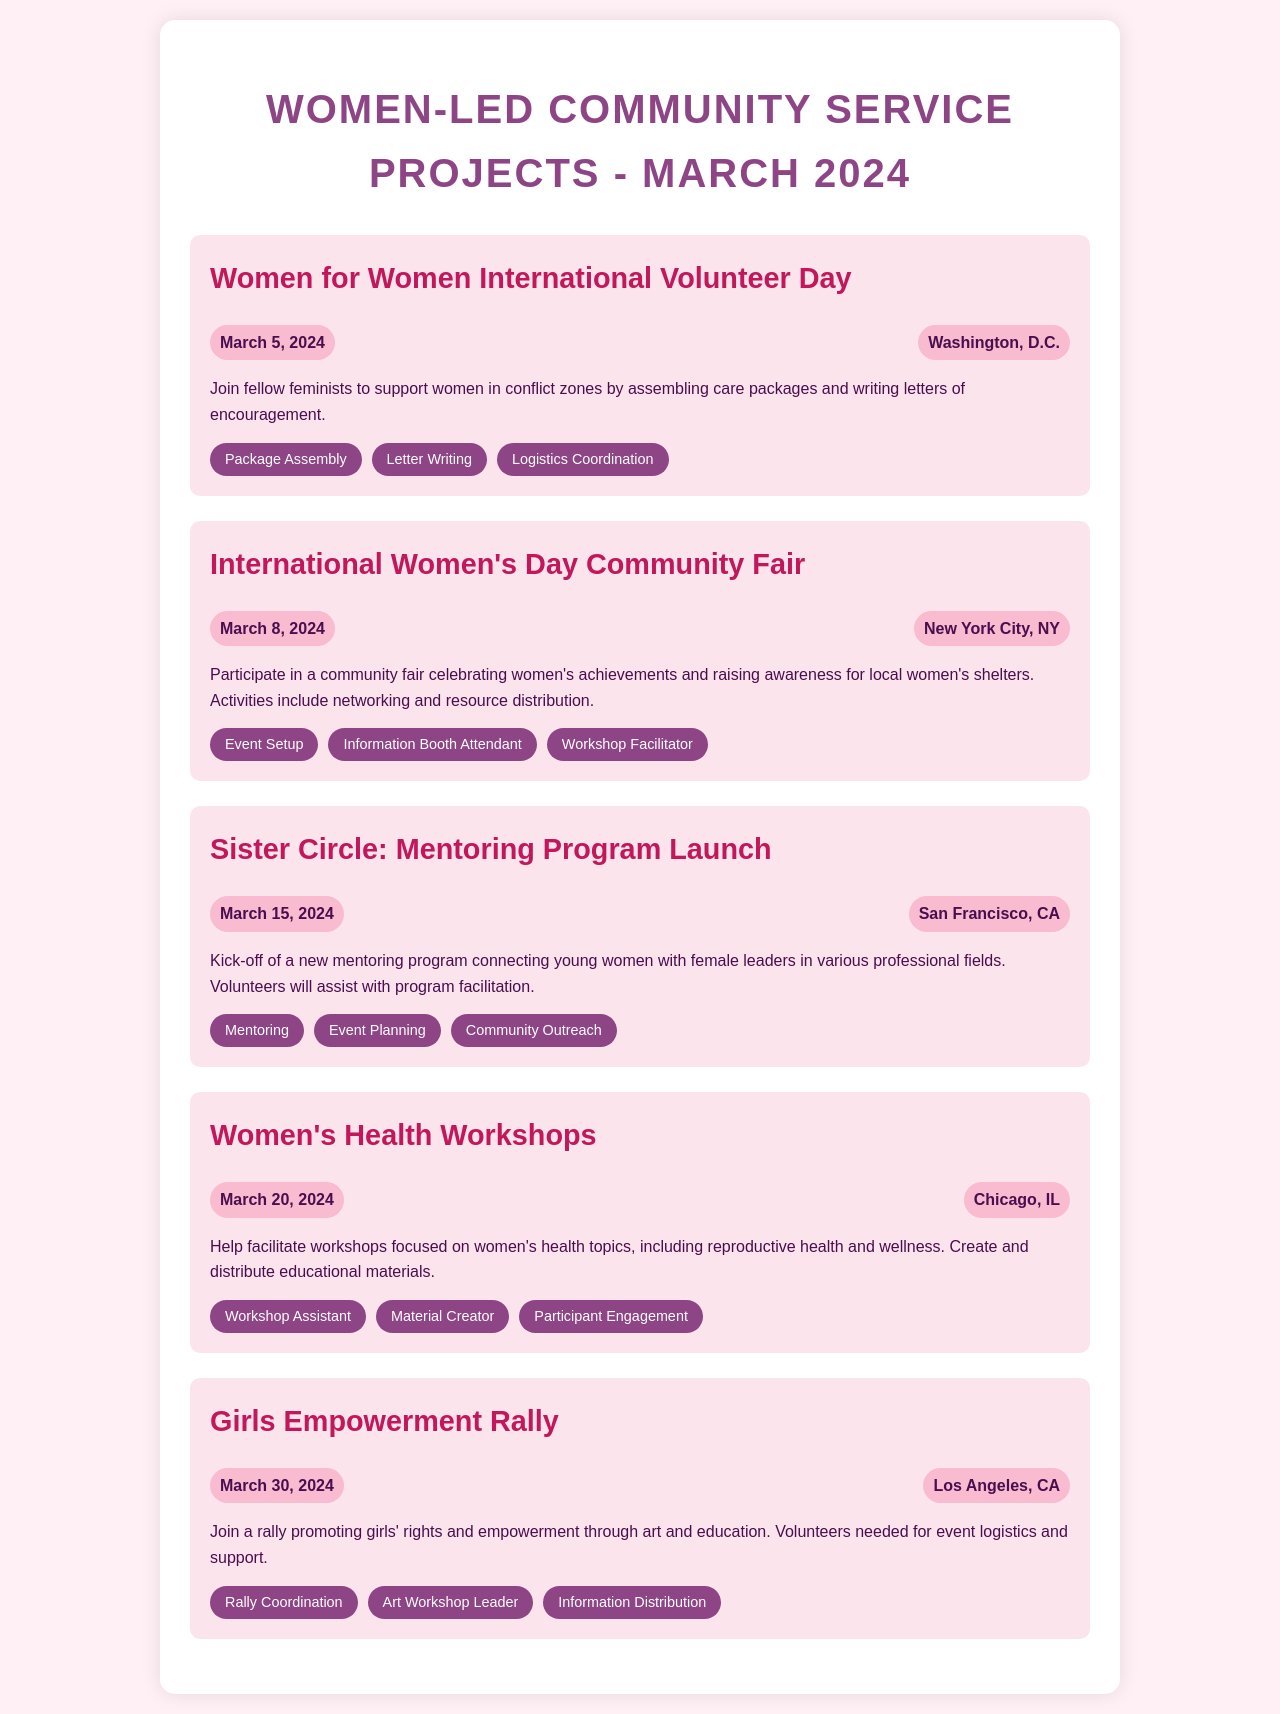What is the date of the Women for Women International Volunteer Day? The document states that the Women for Women International Volunteer Day is scheduled for March 5, 2024.
Answer: March 5, 2024 Where is the International Women's Day Community Fair taking place? According to the schedule, the International Women's Day Community Fair will be held in New York City, NY.
Answer: New York City, NY What volunteer role is involved in the Girls Empowerment Rally? The document lists "Rally Coordination" as one of the volunteer roles needed for the Girls Empowerment Rally.
Answer: Rally Coordination What is the main activity planned for March 15, 2024? The document indicates that the main activity planned for March 15, 2024, is the launch of the Sister Circle mentoring program.
Answer: Launch of the Sister Circle mentoring program How many different volunteer roles are listed for the Women's Health Workshops? The document indicates there are three distinct volunteer roles listed for the Women's Health Workshops.
Answer: Three What type of event will be celebrated on March 8, 2024? The schedule highlights that March 8, 2024, will celebrate International Women's Day through a Community Fair.
Answer: International Women's Day Community Fair Which city will host the rally focusing on girls' rights and empowerment? According to the document, the rally promoting girls' rights and empowerment will be hosted in Los Angeles, CA.
Answer: Los Angeles, CA What role involves assisting with program facilitation on March 15? The document notes that the role of "Event Planning" involves assisting with program facilitation for the Sister Circle mentoring program.
Answer: Event Planning 